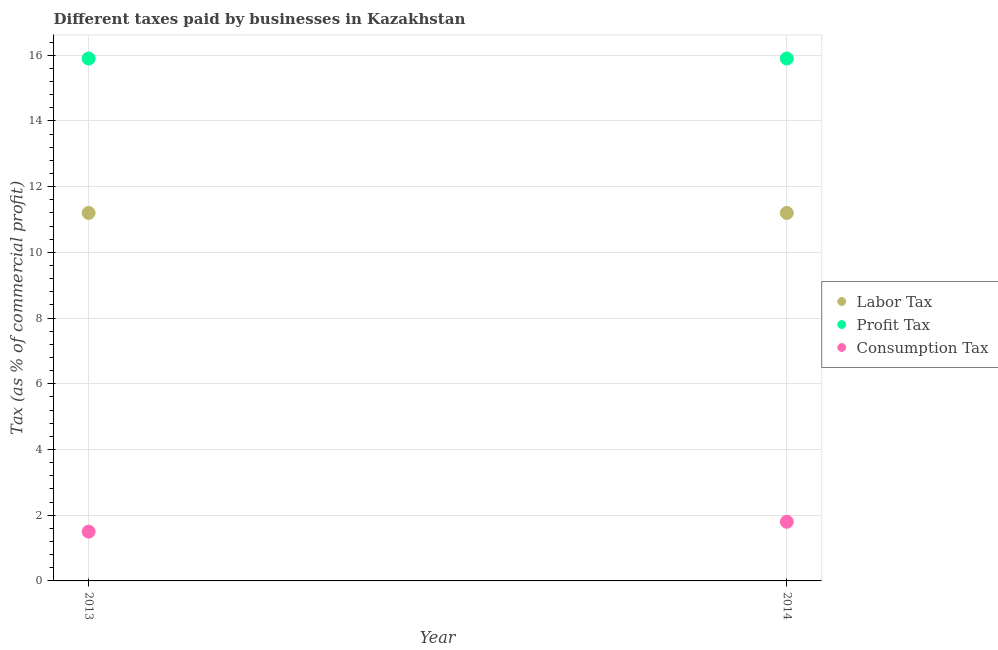How many different coloured dotlines are there?
Keep it short and to the point. 3. In which year was the percentage of labor tax minimum?
Keep it short and to the point. 2013. What is the difference between the percentage of labor tax in 2014 and the percentage of profit tax in 2013?
Your response must be concise. -4.7. What is the average percentage of consumption tax per year?
Offer a terse response. 1.65. What is the ratio of the percentage of labor tax in 2013 to that in 2014?
Provide a short and direct response. 1. Is it the case that in every year, the sum of the percentage of labor tax and percentage of profit tax is greater than the percentage of consumption tax?
Ensure brevity in your answer.  Yes. Does the percentage of profit tax monotonically increase over the years?
Keep it short and to the point. No. Is the percentage of consumption tax strictly greater than the percentage of profit tax over the years?
Provide a succinct answer. No. How many years are there in the graph?
Give a very brief answer. 2. What is the difference between two consecutive major ticks on the Y-axis?
Your answer should be compact. 2. Does the graph contain any zero values?
Keep it short and to the point. No. Does the graph contain grids?
Provide a short and direct response. Yes. How many legend labels are there?
Offer a terse response. 3. How are the legend labels stacked?
Keep it short and to the point. Vertical. What is the title of the graph?
Offer a very short reply. Different taxes paid by businesses in Kazakhstan. What is the label or title of the X-axis?
Provide a short and direct response. Year. What is the label or title of the Y-axis?
Provide a succinct answer. Tax (as % of commercial profit). What is the Tax (as % of commercial profit) of Profit Tax in 2014?
Your answer should be very brief. 15.9. What is the Tax (as % of commercial profit) of Consumption Tax in 2014?
Your response must be concise. 1.8. Across all years, what is the maximum Tax (as % of commercial profit) of Profit Tax?
Provide a succinct answer. 15.9. Across all years, what is the minimum Tax (as % of commercial profit) in Labor Tax?
Your answer should be compact. 11.2. Across all years, what is the minimum Tax (as % of commercial profit) of Consumption Tax?
Provide a succinct answer. 1.5. What is the total Tax (as % of commercial profit) of Labor Tax in the graph?
Ensure brevity in your answer.  22.4. What is the total Tax (as % of commercial profit) in Profit Tax in the graph?
Give a very brief answer. 31.8. What is the difference between the Tax (as % of commercial profit) of Labor Tax in 2013 and that in 2014?
Make the answer very short. 0. What is the difference between the Tax (as % of commercial profit) of Profit Tax in 2013 and that in 2014?
Provide a succinct answer. 0. What is the difference between the Tax (as % of commercial profit) of Labor Tax in 2013 and the Tax (as % of commercial profit) of Profit Tax in 2014?
Offer a terse response. -4.7. What is the difference between the Tax (as % of commercial profit) of Labor Tax in 2013 and the Tax (as % of commercial profit) of Consumption Tax in 2014?
Give a very brief answer. 9.4. What is the average Tax (as % of commercial profit) of Labor Tax per year?
Your answer should be compact. 11.2. What is the average Tax (as % of commercial profit) of Profit Tax per year?
Give a very brief answer. 15.9. What is the average Tax (as % of commercial profit) of Consumption Tax per year?
Give a very brief answer. 1.65. In the year 2013, what is the difference between the Tax (as % of commercial profit) in Profit Tax and Tax (as % of commercial profit) in Consumption Tax?
Keep it short and to the point. 14.4. In the year 2014, what is the difference between the Tax (as % of commercial profit) of Labor Tax and Tax (as % of commercial profit) of Consumption Tax?
Ensure brevity in your answer.  9.4. What is the ratio of the Tax (as % of commercial profit) of Profit Tax in 2013 to that in 2014?
Your answer should be very brief. 1. What is the ratio of the Tax (as % of commercial profit) of Consumption Tax in 2013 to that in 2014?
Your response must be concise. 0.83. What is the difference between the highest and the second highest Tax (as % of commercial profit) in Profit Tax?
Your response must be concise. 0. What is the difference between the highest and the second highest Tax (as % of commercial profit) in Consumption Tax?
Ensure brevity in your answer.  0.3. What is the difference between the highest and the lowest Tax (as % of commercial profit) in Labor Tax?
Your response must be concise. 0. What is the difference between the highest and the lowest Tax (as % of commercial profit) in Profit Tax?
Make the answer very short. 0. 